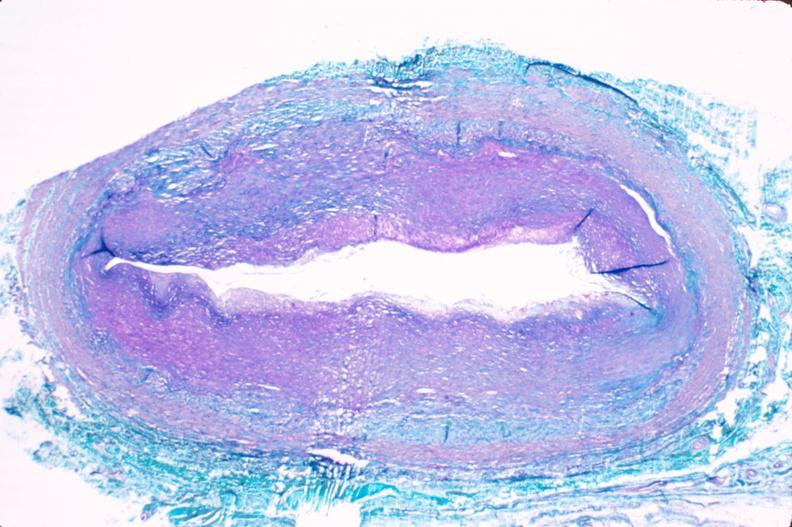s cardiovascular present?
Answer the question using a single word or phrase. Yes 